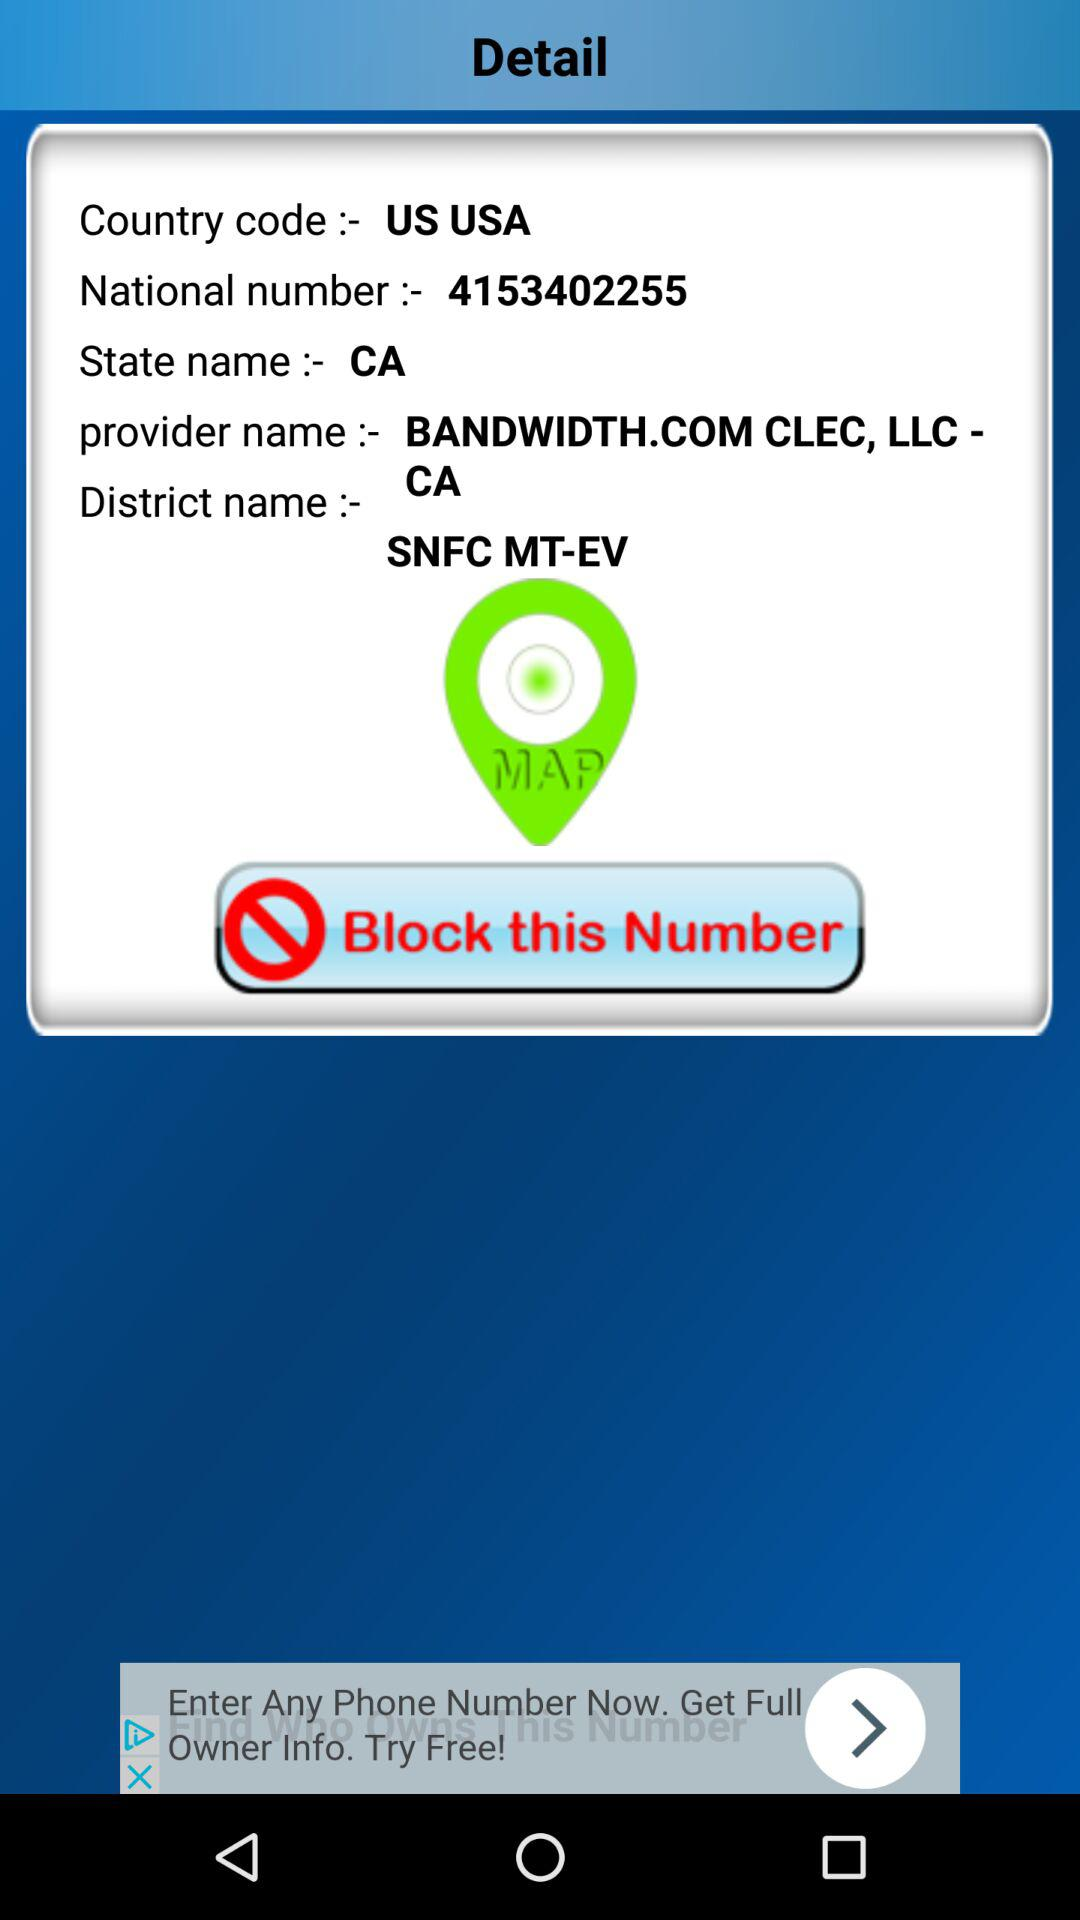What is the state name? The state name is California. 